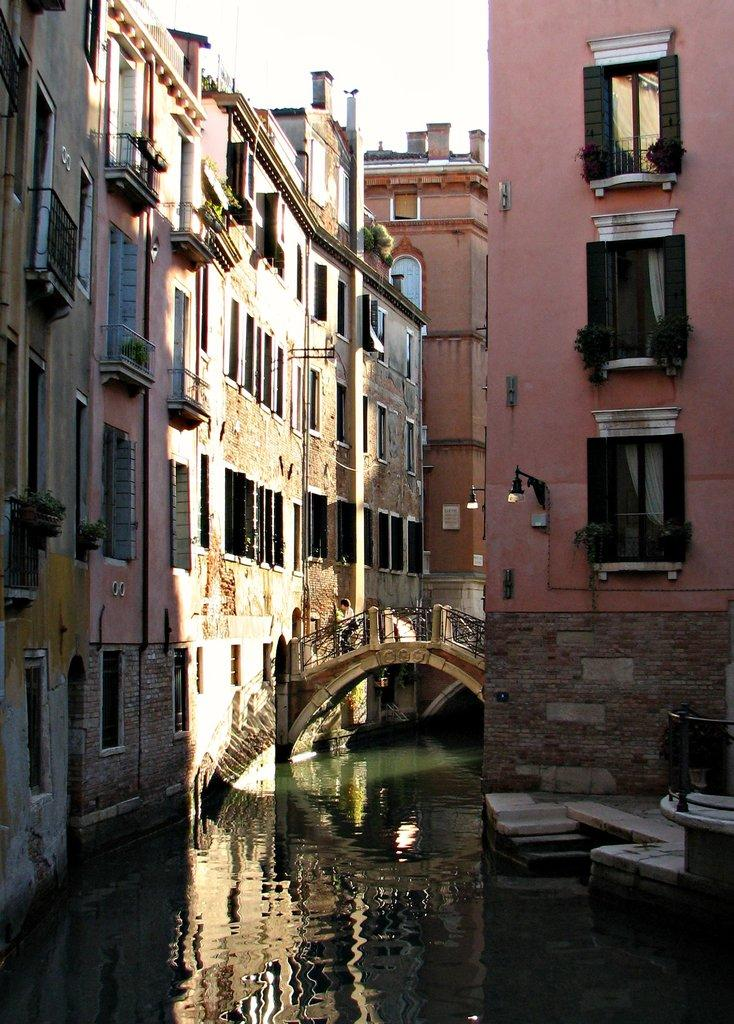What type of structures can be seen in the image? There are buildings in the image. What architectural feature is present in the buildings? There are windows in the image. What is the person in the image doing? There is a person walking on a bridge in the image. What type of vegetation is present in the image? There are house plants in the image. What source of illumination is visible in the image? There is a light in the image. What natural element is visible in the image? There is water visible in the image. What part of the natural environment is visible in the image? The sky is visible in the image. Where is the sofa located in the image? There is no sofa present in the image. Can you see a tiger walking on the bridge in the image? There is no tiger present in the image; it is a person walking on the bridge. 